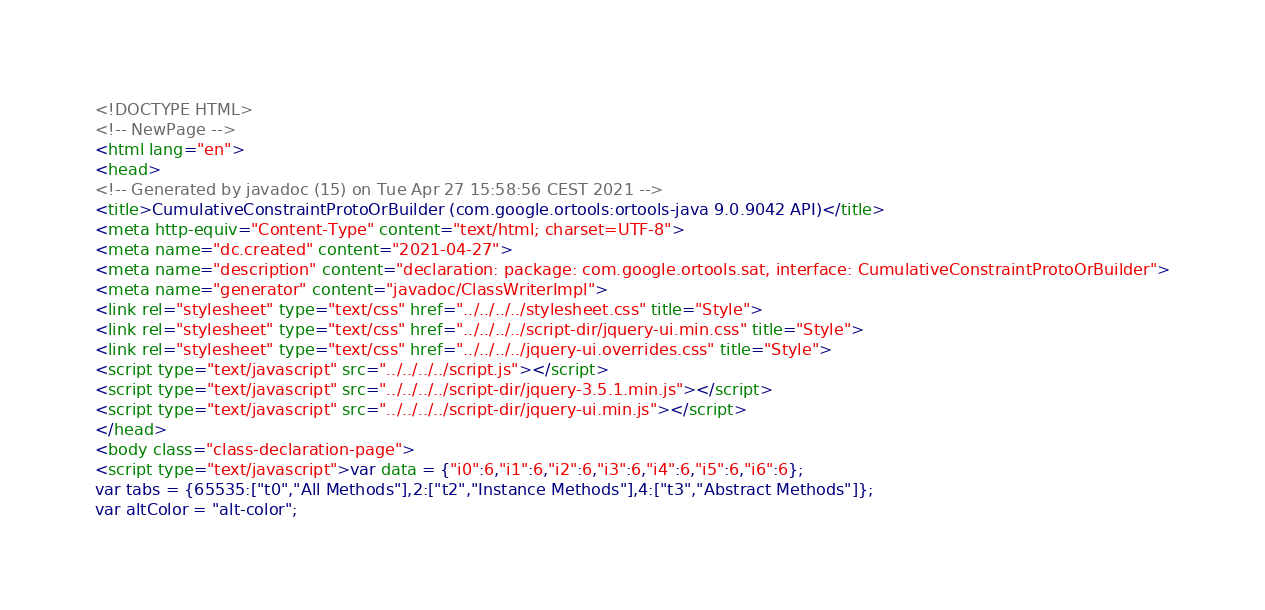Convert code to text. <code><loc_0><loc_0><loc_500><loc_500><_HTML_><!DOCTYPE HTML>
<!-- NewPage -->
<html lang="en">
<head>
<!-- Generated by javadoc (15) on Tue Apr 27 15:58:56 CEST 2021 -->
<title>CumulativeConstraintProtoOrBuilder (com.google.ortools:ortools-java 9.0.9042 API)</title>
<meta http-equiv="Content-Type" content="text/html; charset=UTF-8">
<meta name="dc.created" content="2021-04-27">
<meta name="description" content="declaration: package: com.google.ortools.sat, interface: CumulativeConstraintProtoOrBuilder">
<meta name="generator" content="javadoc/ClassWriterImpl">
<link rel="stylesheet" type="text/css" href="../../../../stylesheet.css" title="Style">
<link rel="stylesheet" type="text/css" href="../../../../script-dir/jquery-ui.min.css" title="Style">
<link rel="stylesheet" type="text/css" href="../../../../jquery-ui.overrides.css" title="Style">
<script type="text/javascript" src="../../../../script.js"></script>
<script type="text/javascript" src="../../../../script-dir/jquery-3.5.1.min.js"></script>
<script type="text/javascript" src="../../../../script-dir/jquery-ui.min.js"></script>
</head>
<body class="class-declaration-page">
<script type="text/javascript">var data = {"i0":6,"i1":6,"i2":6,"i3":6,"i4":6,"i5":6,"i6":6};
var tabs = {65535:["t0","All Methods"],2:["t2","Instance Methods"],4:["t3","Abstract Methods"]};
var altColor = "alt-color";</code> 